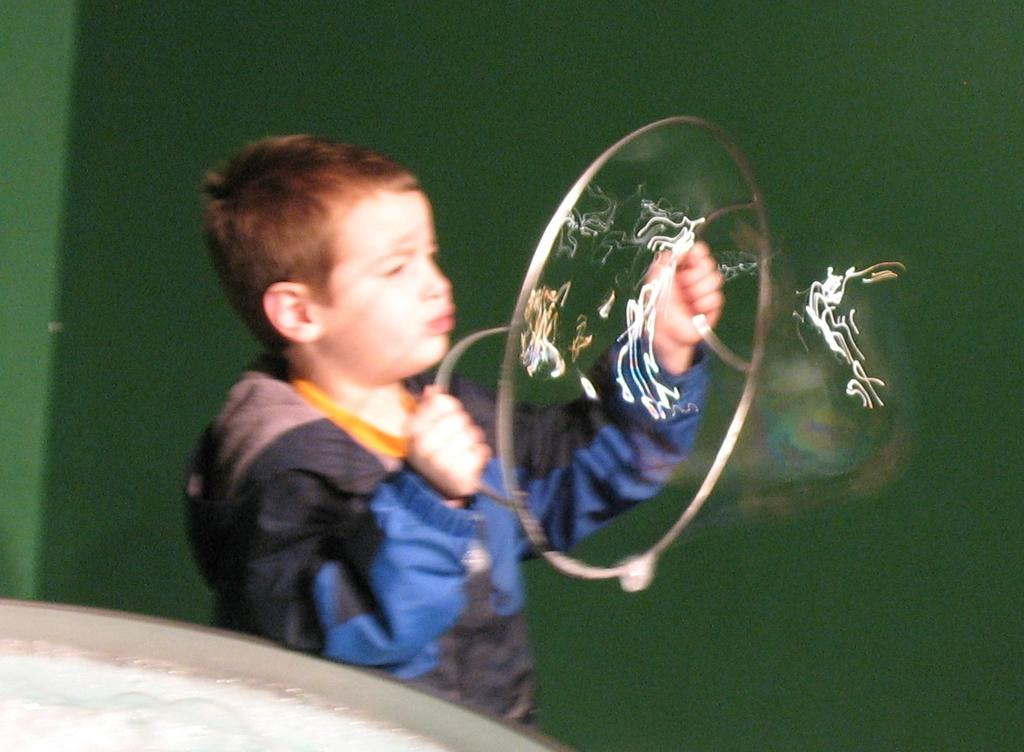Who is the main subject in the image? There is a boy in the image. What is the boy holding in his hand? The boy is holding an object in his hand. What color dominates the background of the image? The background of the image is covered with green color. Can you determine the time of day when the image was taken? The image was likely taken during the day, as there is sufficient light. What type of account does the boy have in the image? There is no mention of an account in the image, as it features a boy holding an object in a green background. What kind of apparel is the boy wearing in the image? The provided facts do not mention the boy's clothing, so we cannot determine the type of apparel he is wearing. 